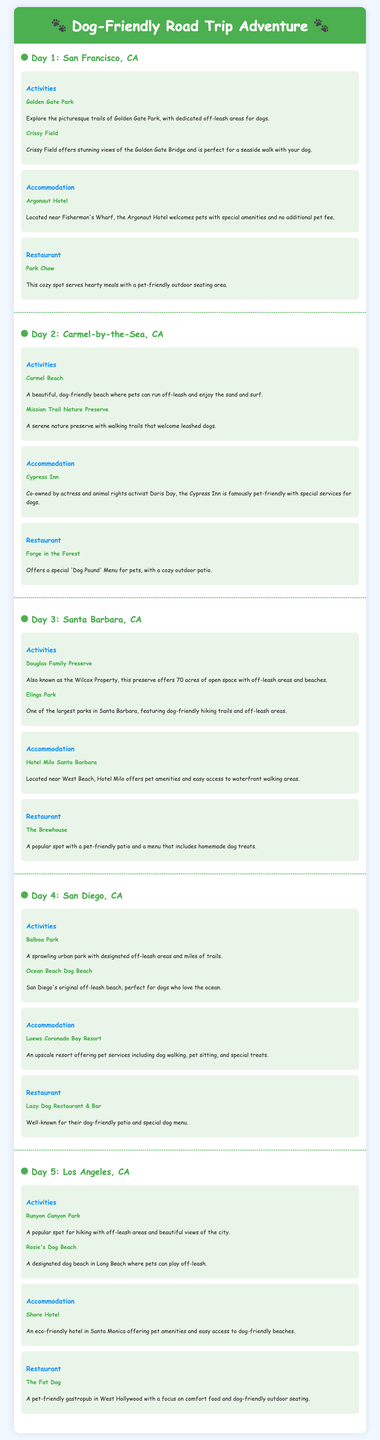What activities can you do on Day 1? The activities listed for Day 1 include exploring Golden Gate Park and visiting Crissy Field.
Answer: Golden Gate Park, Crissy Field What is the name of the hotel in Carmel-by-the-Sea? The accommodation listed for Day 2 is the Cypress Inn.
Answer: Cypress Inn Which restaurant offers a 'Dog Pound' Menu? The restaurant mentioned for Day 2 that offers a special menu for dogs is Forge in the Forest.
Answer: Forge in the Forest How many acres is the Douglas Family Preserve? The Douglas Family Preserve offers 70 acres of open space.
Answer: 70 acres What type of beach is Ocean Beach Dog Beach? Ocean Beach Dog Beach is referred to as San Diego's original off-leash beach.
Answer: Off-leash beach 